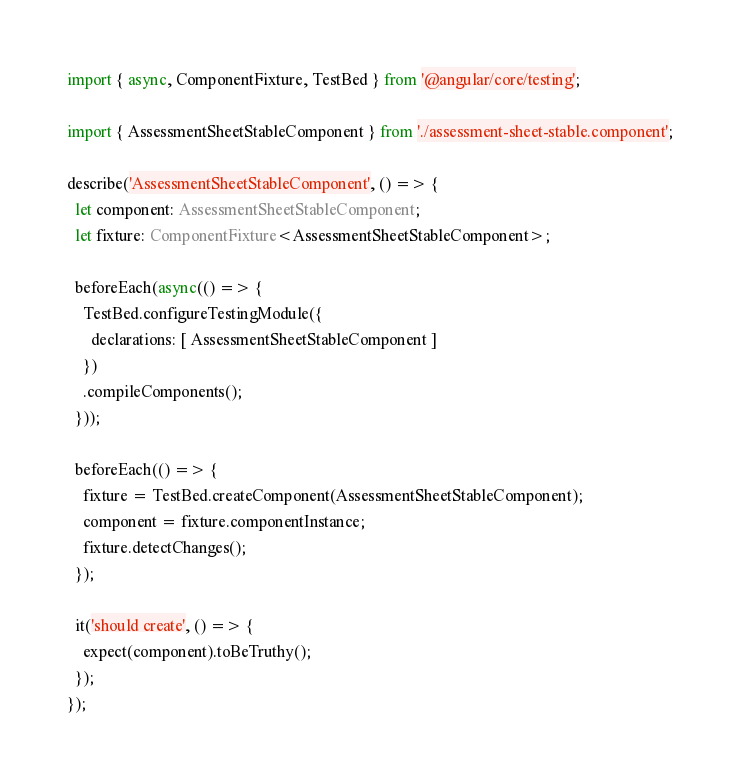<code> <loc_0><loc_0><loc_500><loc_500><_TypeScript_>import { async, ComponentFixture, TestBed } from '@angular/core/testing';

import { AssessmentSheetStableComponent } from './assessment-sheet-stable.component';

describe('AssessmentSheetStableComponent', () => {
  let component: AssessmentSheetStableComponent;
  let fixture: ComponentFixture<AssessmentSheetStableComponent>;

  beforeEach(async(() => {
    TestBed.configureTestingModule({
      declarations: [ AssessmentSheetStableComponent ]
    })
    .compileComponents();
  }));

  beforeEach(() => {
    fixture = TestBed.createComponent(AssessmentSheetStableComponent);
    component = fixture.componentInstance;
    fixture.detectChanges();
  });

  it('should create', () => {
    expect(component).toBeTruthy();
  });
});
</code> 